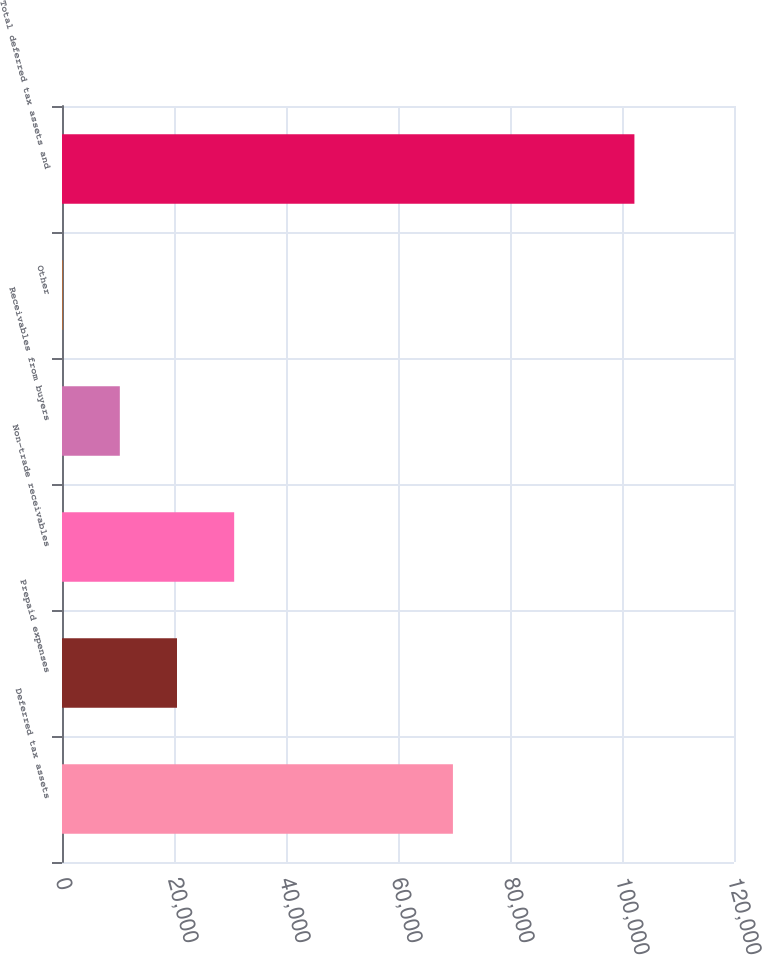Convert chart. <chart><loc_0><loc_0><loc_500><loc_500><bar_chart><fcel>Deferred tax assets<fcel>Prepaid expenses<fcel>Non-trade receivables<fcel>Receivables from buyers<fcel>Other<fcel>Total deferred tax assets and<nl><fcel>69807<fcel>20535.4<fcel>30745.6<fcel>10325.2<fcel>115<fcel>102217<nl></chart> 